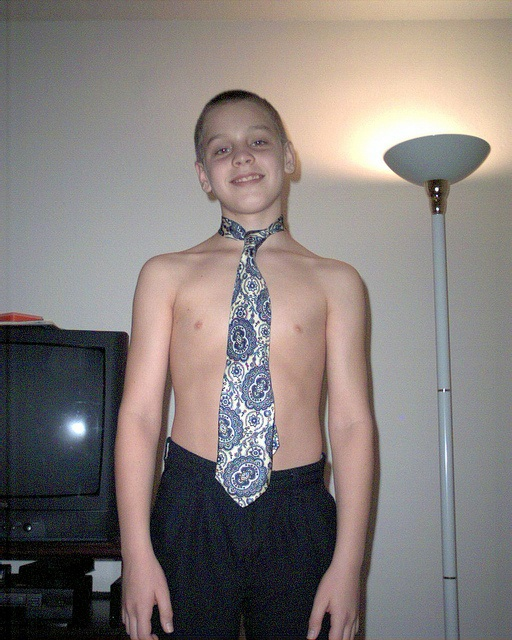Describe the objects in this image and their specific colors. I can see people in darkgreen, black, darkgray, tan, and gray tones, tv in darkgreen, black, blue, and gray tones, and tie in darkgreen, ivory, gray, and darkgray tones in this image. 